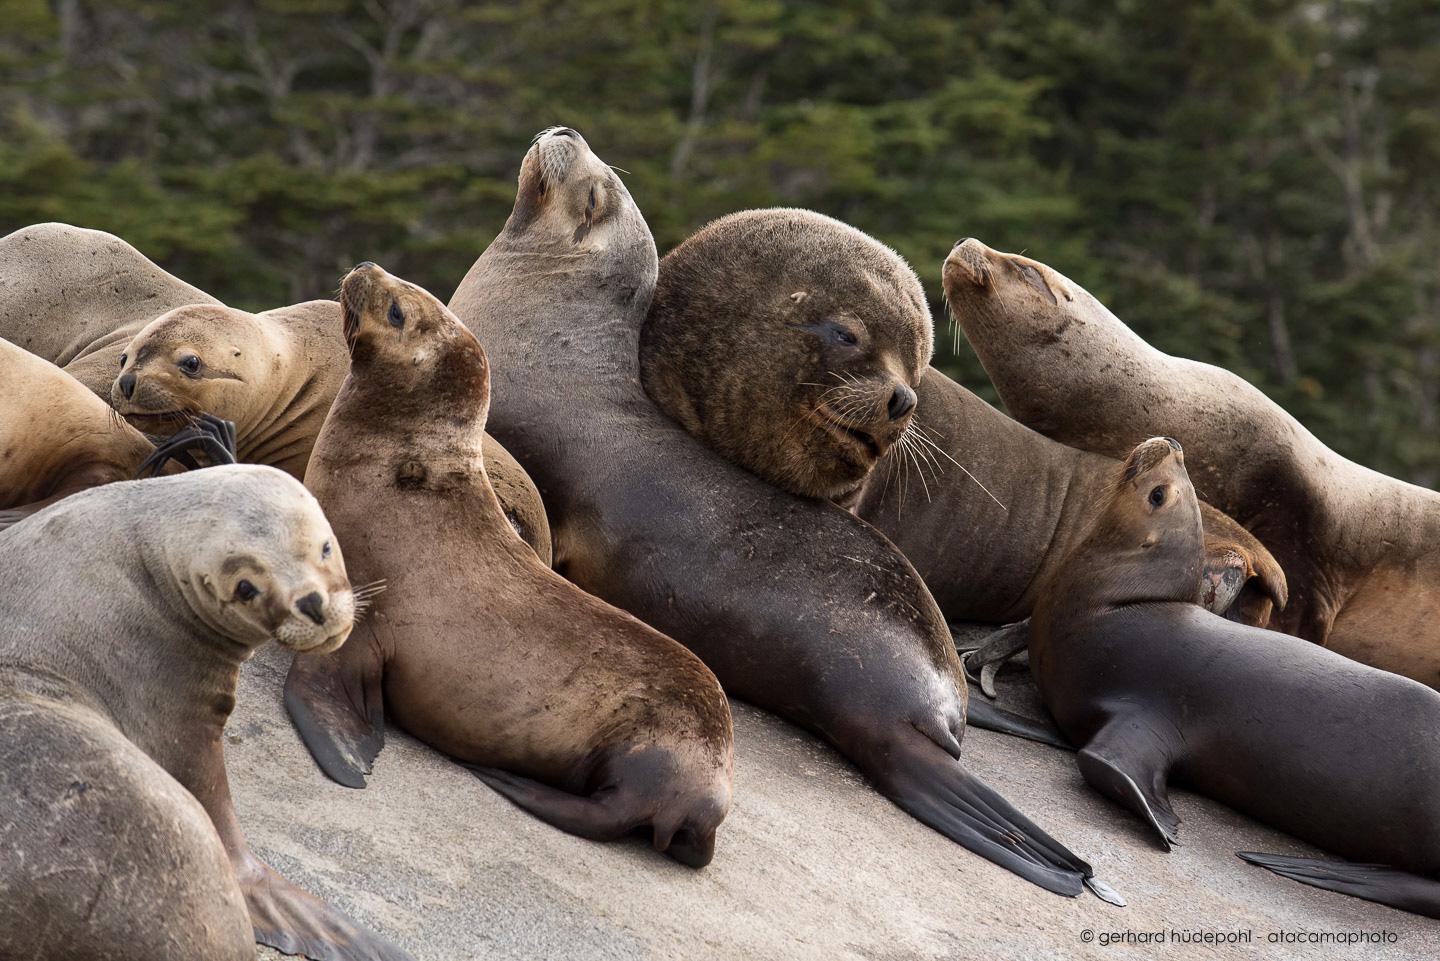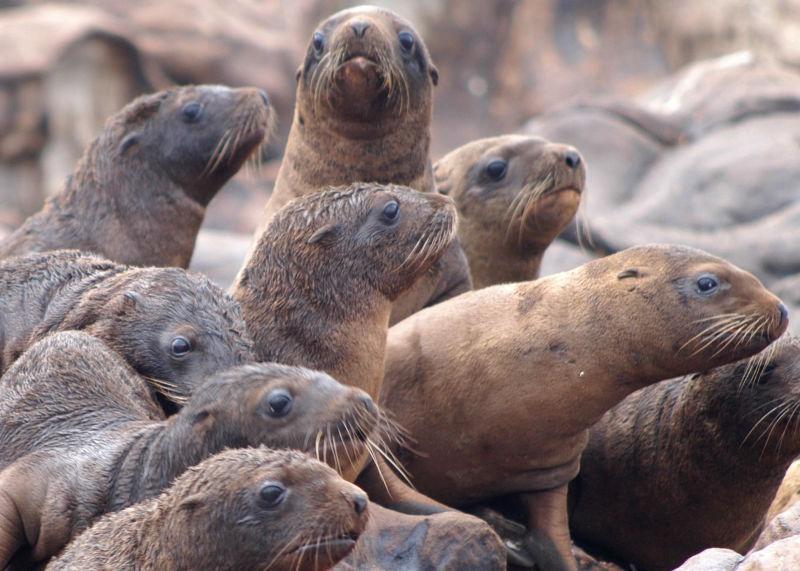The first image is the image on the left, the second image is the image on the right. Analyze the images presented: Is the assertion "At least one seal is showing its teeth." valid? Answer yes or no. No. The first image is the image on the left, the second image is the image on the right. Examine the images to the left and right. Is the description "One of the seals has his mouth open in the left image." accurate? Answer yes or no. No. 